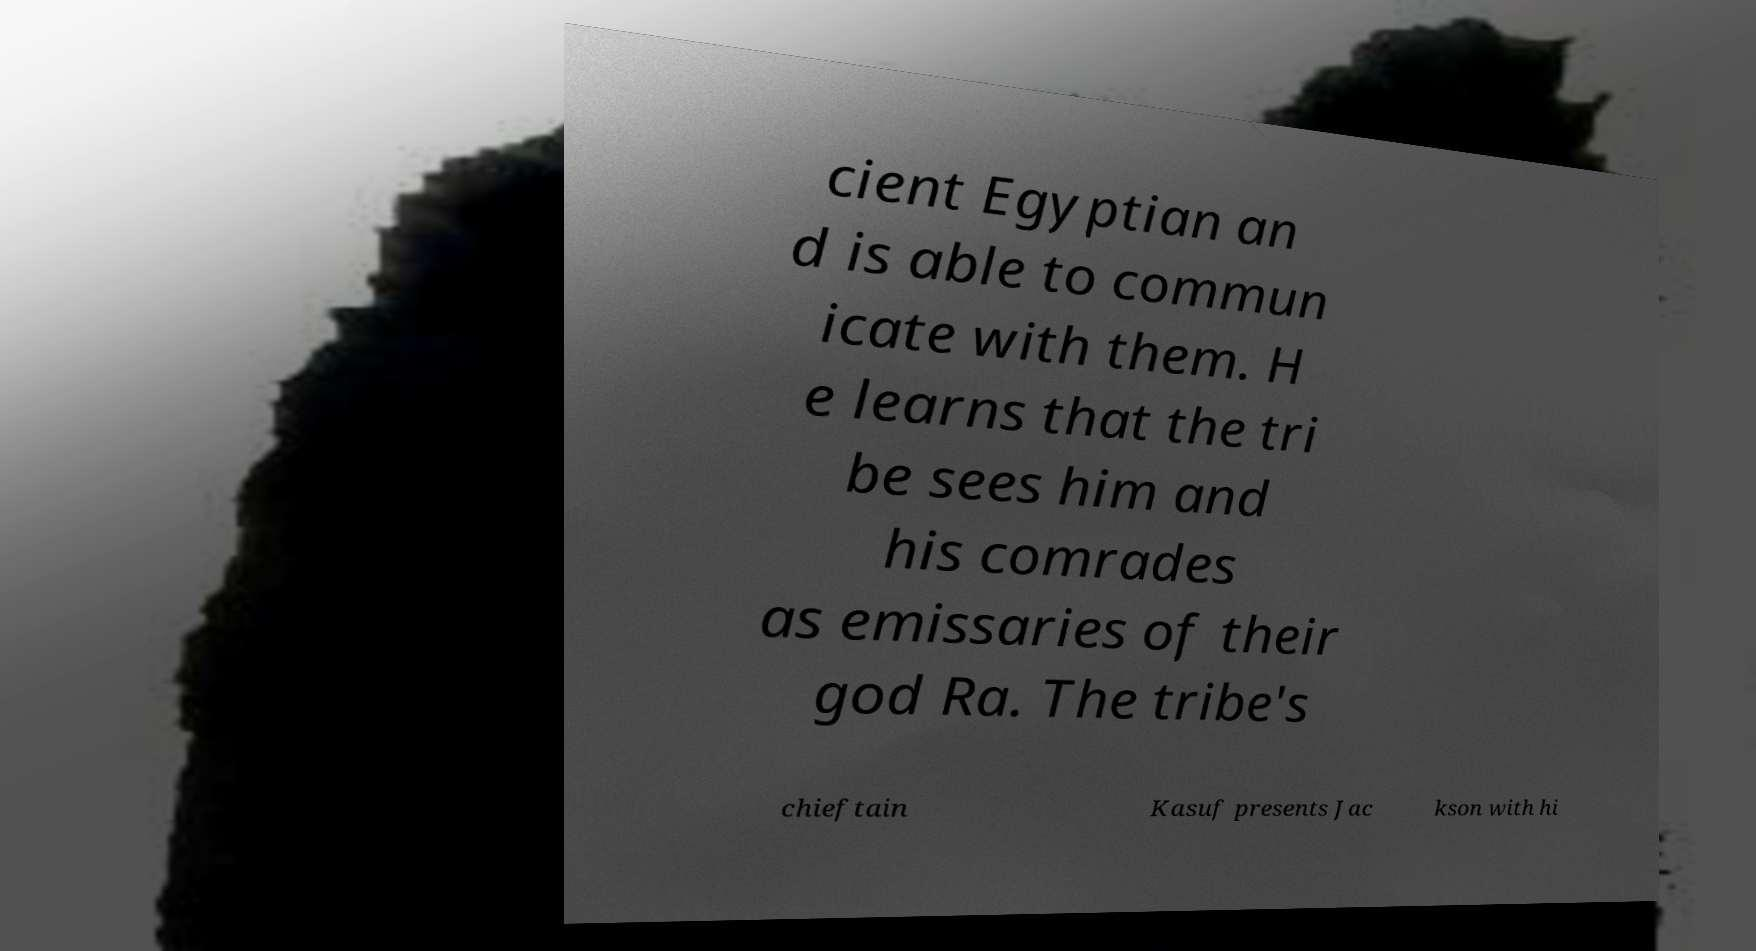Please read and relay the text visible in this image. What does it say? cient Egyptian an d is able to commun icate with them. H e learns that the tri be sees him and his comrades as emissaries of their god Ra. The tribe's chieftain Kasuf presents Jac kson with hi 